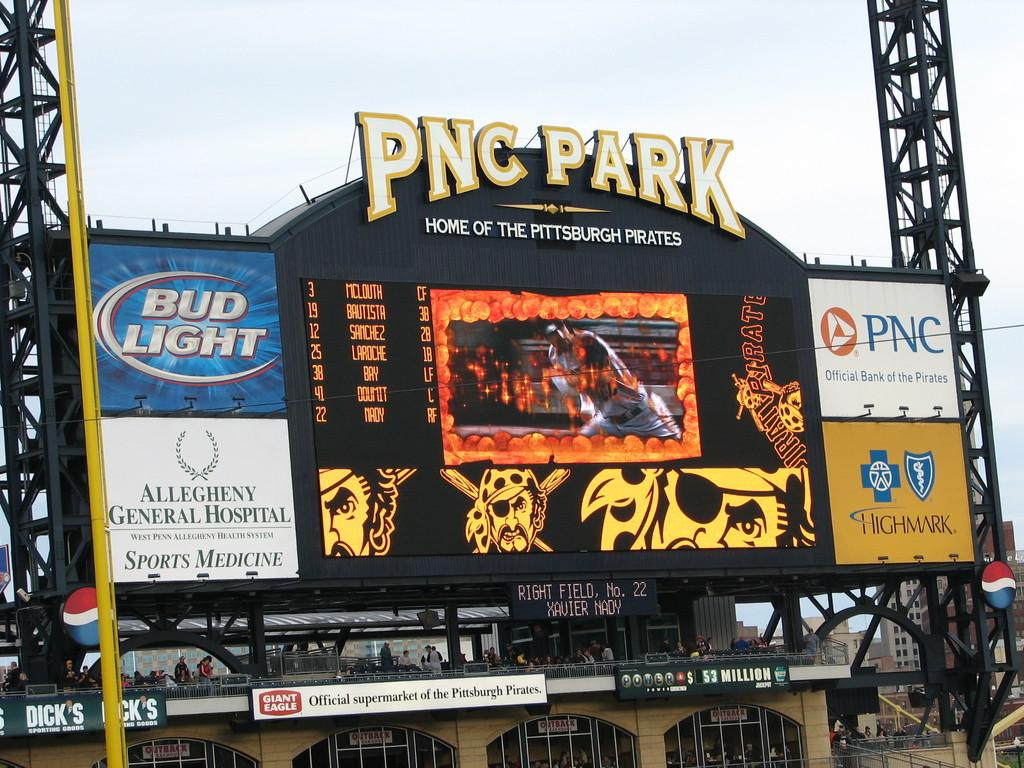<image>
Write a terse but informative summary of the picture. An electronic billboard at the home of the Pittsburgh Pirates is showing scores and advertisements for Bud Light, Allegheny General Hospital, PNC, And Highmark. 